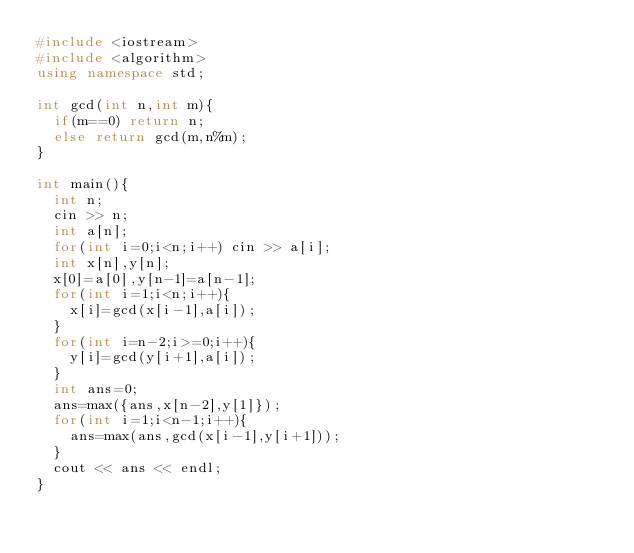<code> <loc_0><loc_0><loc_500><loc_500><_C++_>#include <iostream>
#include <algorithm>
using namespace std;

int gcd(int n,int m){
  if(m==0) return n;
  else return gcd(m,n%m);
}

int main(){
  int n;
  cin >> n;
  int a[n];
  for(int i=0;i<n;i++) cin >> a[i];
  int x[n],y[n];
  x[0]=a[0],y[n-1]=a[n-1];
  for(int i=1;i<n;i++){
    x[i]=gcd(x[i-1],a[i]);
  }
  for(int i=n-2;i>=0;i++){
    y[i]=gcd(y[i+1],a[i]);
  }
  int ans=0;
  ans=max({ans,x[n-2],y[1]});
  for(int i=1;i<n-1;i++){
    ans=max(ans,gcd(x[i-1],y[i+1]));
  }
  cout << ans << endl;
}
</code> 